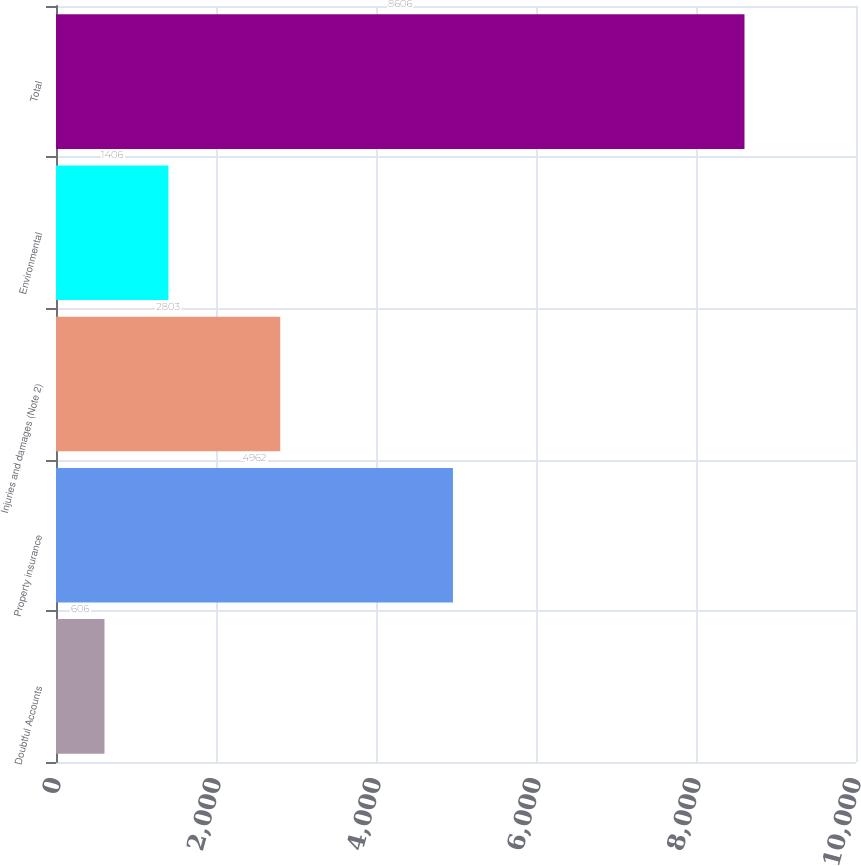Convert chart. <chart><loc_0><loc_0><loc_500><loc_500><bar_chart><fcel>Doubtful Accounts<fcel>Property insurance<fcel>Injuries and damages (Note 2)<fcel>Environmental<fcel>Total<nl><fcel>606<fcel>4962<fcel>2803<fcel>1406<fcel>8606<nl></chart> 